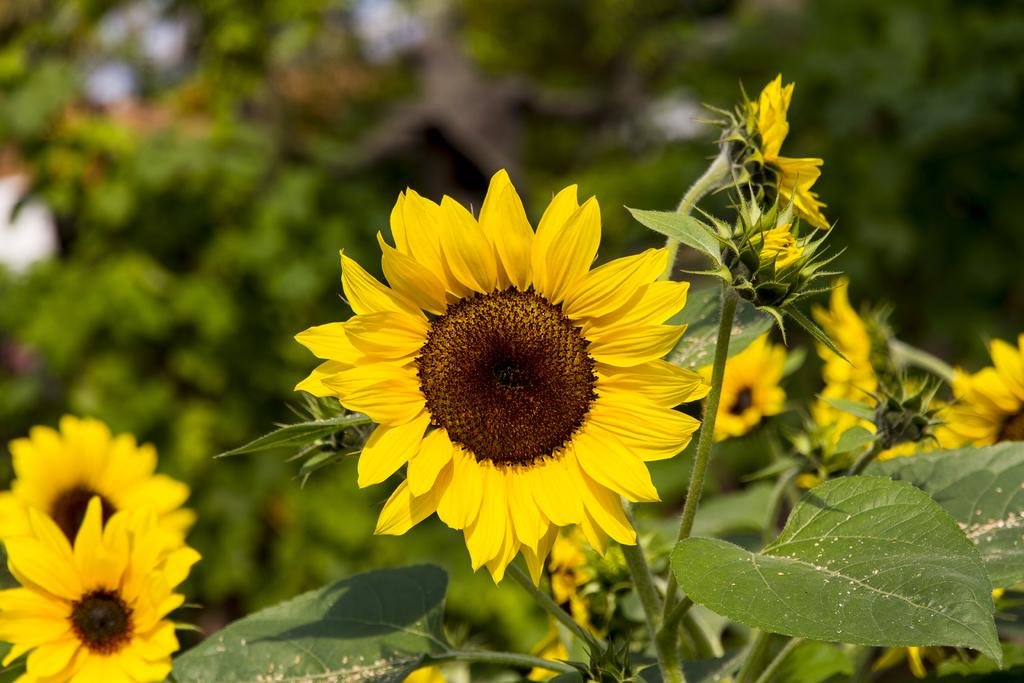What type of plants can be seen in the image? There are plants in the image with yellow sunflowers. What color are the leaves of the plants in the image? The plants have green leaves. Can you describe the background of the image? The background of the image is blurred. How many goldfish are swimming in the image? There are no goldfish present in the image. What advice might the grandmother give about the plants in the image? There is no grandmother present in the image, so it is not possible to determine what advice she might give. 